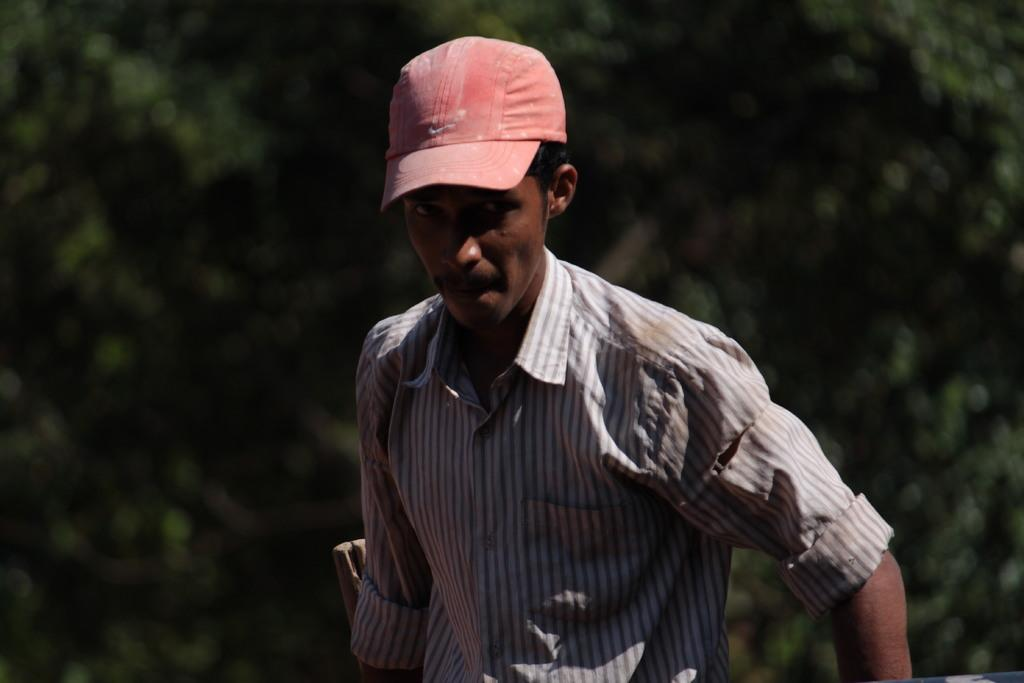What can be observed about the background of the image? The background portion of the picture is blurred. Can you describe the person in the image? There is a man in the image. What type of clothing is the man wearing on his upper body? The man is wearing a shirt. What type of headwear is the man wearing? The man is wearing a cap. What type of jeans is the man wearing in the image? There is no mention of jeans in the provided facts, so we cannot determine the type of jeans the man is wearing. 